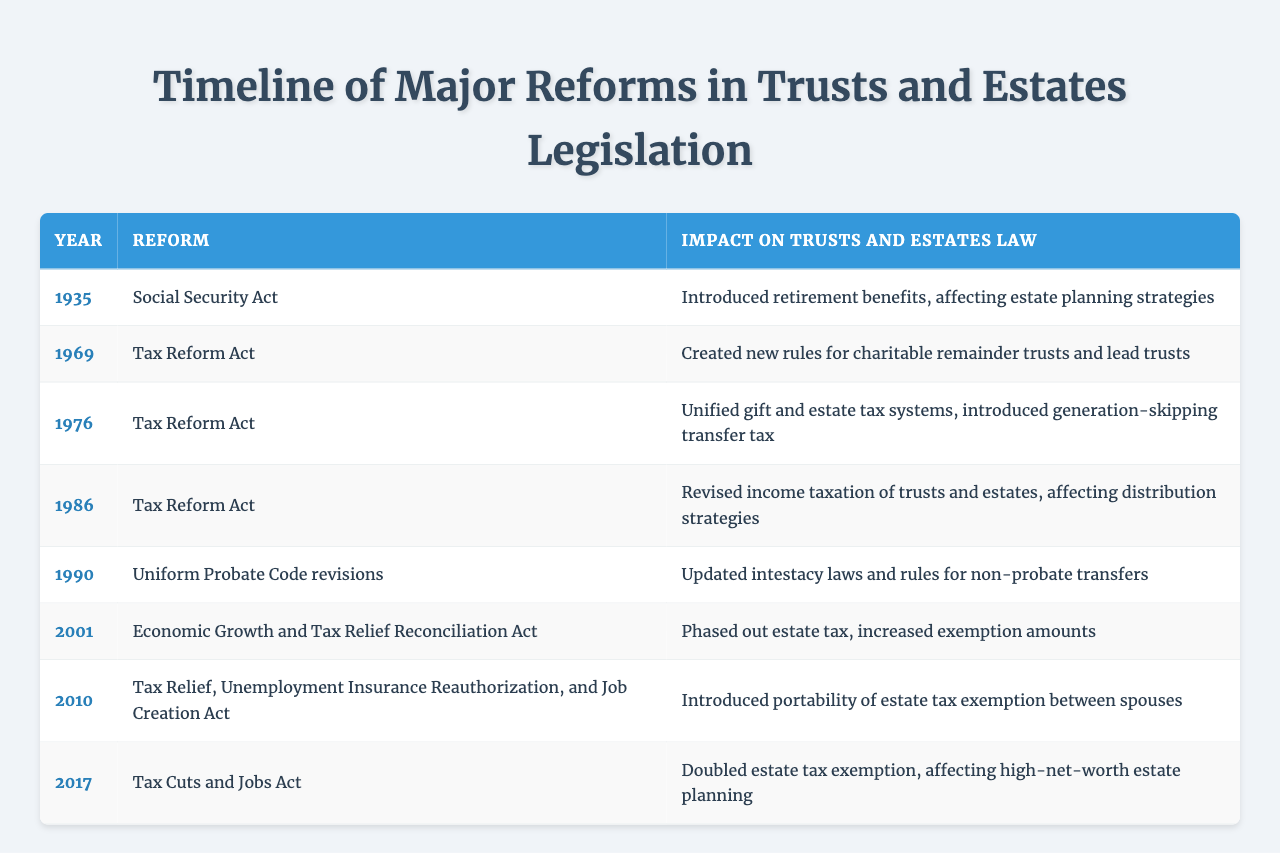What reform was enacted in 1976? The table shows that the reform in 1976 was the Tax Reform Act.
Answer: Tax Reform Act What year saw the introduction of the portability of estate tax exemption between spouses? According to the table, this reform was introduced in the year 2010.
Answer: 2010 Which reform had a significant impact on estate planning strategies due to the introduction of retirement benefits? The Social Security Act of 1935 had a significant impact by introducing retirement benefits.
Answer: Social Security Act Did the Tax Cuts and Jobs Act double the estate tax exemption? Yes, the table indicates that the Tax Cuts and Jobs Act in 2017 doubled the estate tax exemption.
Answer: Yes How many reforms were introduced in the 1980s? There are two reforms listed in the table from the 1980s: the Tax Reform Act in 1986. Therefore, the total is 1.
Answer: 1 What was the common theme of the reforms listed in the years 1969, 1976, and 1986? The common theme among these reforms is that they all are Tax Reform Acts, which addressed taxation related to trusts and estates.
Answer: Tax reforms From 1935 to 2017, how many times did reforms specifically focus on estate taxes? The table lists three specific reforms that focused on estate taxes: the 1976 Tax Reform Act, the 2001 Economic Growth and Tax Relief Reconciliation Act, and the 2017 Tax Cuts and Jobs Act, totaling three.
Answer: 3 Which reform made updates to intestacy laws and non-probate transfers? The Uniform Probate Code revisions in 1990 updated intestacy laws and rules for non-probate transfers accordingly.
Answer: Uniform Probate Code revisions What was the overall impact of the 2001 Economic Growth and Tax Relief Reconciliation Act on estate tax exemption amounts? This act phased out the estate tax and increased exemption amounts, indicating a significant reduction in the estate tax burden.
Answer: Increased exemption amounts In which years did reforms occur that were centered around tax laws? The reforms centered around tax laws occurred in 1969, 1976, 1986, 2001, 2010, and 2017, totaling six years.
Answer: 6 years 